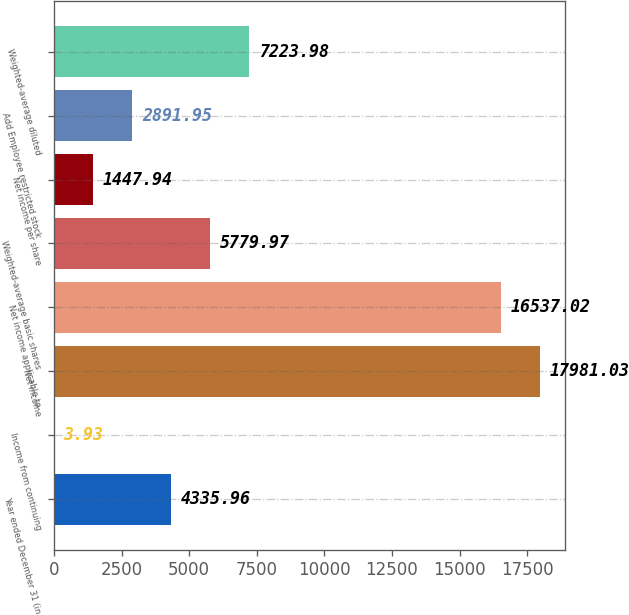Convert chart to OTSL. <chart><loc_0><loc_0><loc_500><loc_500><bar_chart><fcel>Year ended December 31 (in<fcel>Income from continuing<fcel>Net income<fcel>Net income applicable to<fcel>Weighted-average basic shares<fcel>Net income per share<fcel>Add Employee restricted stock<fcel>Weighted-average diluted<nl><fcel>4335.96<fcel>3.93<fcel>17981<fcel>16537<fcel>5779.97<fcel>1447.94<fcel>2891.95<fcel>7223.98<nl></chart> 